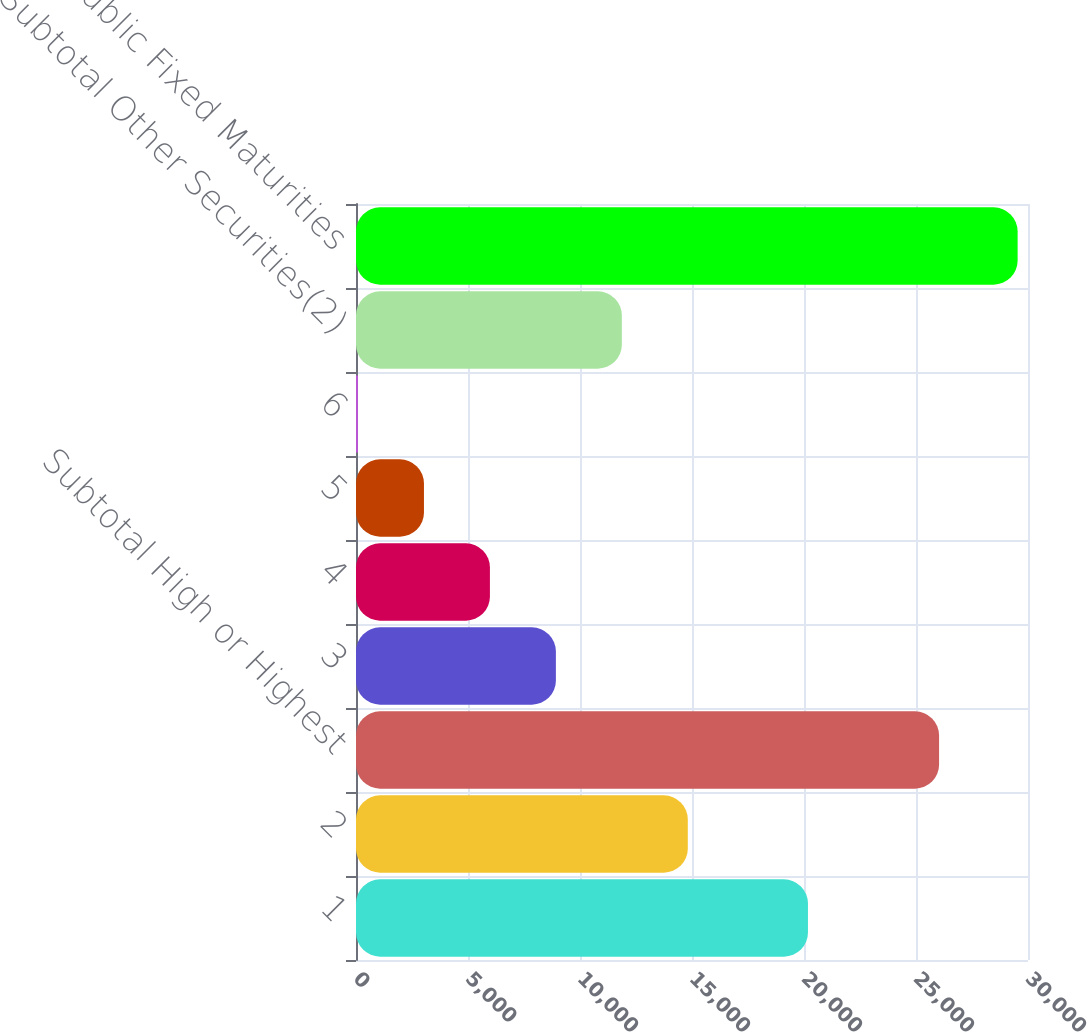Convert chart. <chart><loc_0><loc_0><loc_500><loc_500><bar_chart><fcel>1<fcel>2<fcel>Subtotal High or Highest<fcel>3<fcel>4<fcel>5<fcel>6<fcel>Subtotal Other Securities(2)<fcel>Total Public Fixed Maturities<nl><fcel>20177<fcel>14813<fcel>26030<fcel>8923.4<fcel>5978.6<fcel>3033.8<fcel>89<fcel>11868.2<fcel>29537<nl></chart> 